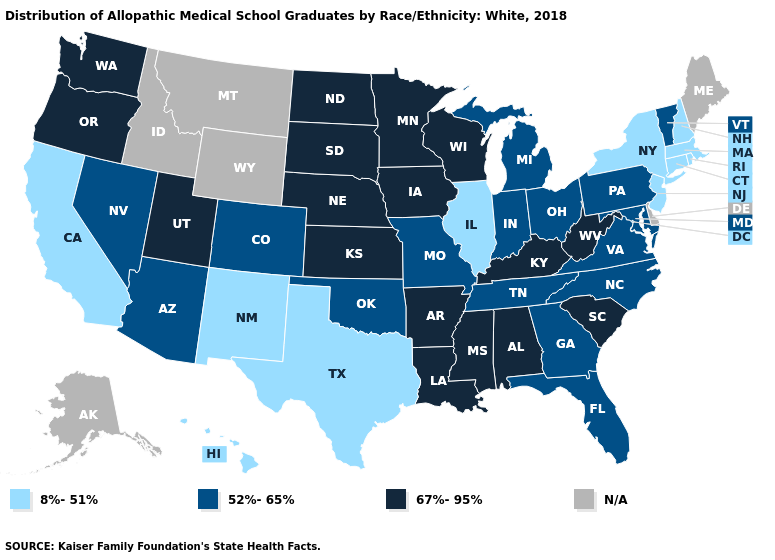Does Nebraska have the lowest value in the USA?
Give a very brief answer. No. Does Vermont have the lowest value in the Northeast?
Short answer required. No. What is the highest value in the South ?
Write a very short answer. 67%-95%. What is the value of Georgia?
Answer briefly. 52%-65%. Name the states that have a value in the range 8%-51%?
Quick response, please. California, Connecticut, Hawaii, Illinois, Massachusetts, New Hampshire, New Jersey, New Mexico, New York, Rhode Island, Texas. What is the lowest value in states that border Minnesota?
Short answer required. 67%-95%. What is the lowest value in the West?
Concise answer only. 8%-51%. What is the lowest value in the Northeast?
Answer briefly. 8%-51%. Name the states that have a value in the range N/A?
Short answer required. Alaska, Delaware, Idaho, Maine, Montana, Wyoming. What is the value of Delaware?
Quick response, please. N/A. Name the states that have a value in the range N/A?
Be succinct. Alaska, Delaware, Idaho, Maine, Montana, Wyoming. What is the value of North Dakota?
Write a very short answer. 67%-95%. What is the lowest value in the USA?
Be succinct. 8%-51%. Which states have the lowest value in the MidWest?
Give a very brief answer. Illinois. What is the value of Wyoming?
Give a very brief answer. N/A. 